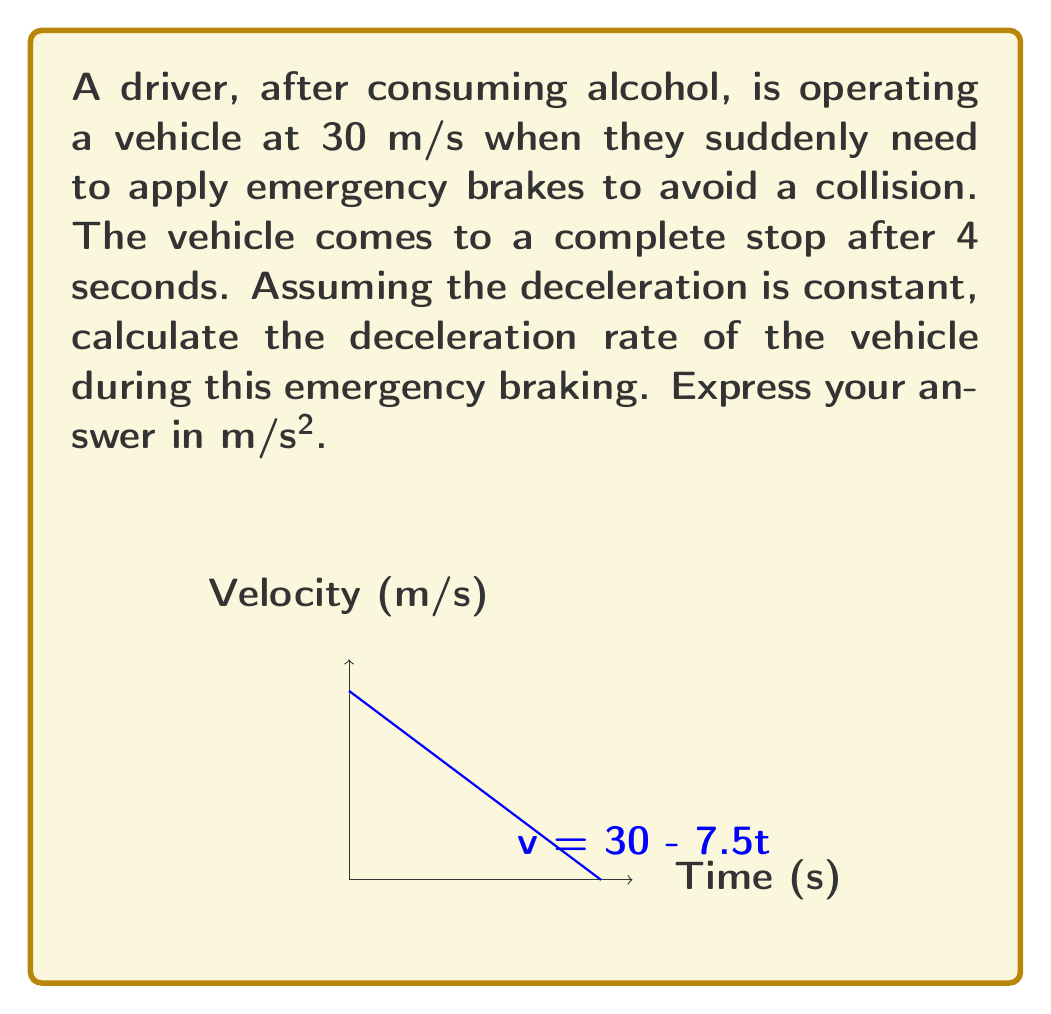Show me your answer to this math problem. To solve this problem, we'll use the equation of motion for constant acceleration:

$$ v = v_0 + at $$

Where:
$v$ = final velocity (0 m/s)
$v_0$ = initial velocity (30 m/s)
$a$ = acceleration (deceleration in this case, which we need to find)
$t$ = time (4 seconds)

Let's substitute these values into the equation:

$$ 0 = 30 + a(4) $$

Now, we can solve for $a$:

$$ -30 = 4a $$
$$ a = -\frac{30}{4} = -7.5 \text{ m/s²} $$

The negative sign indicates that it's a deceleration (slowing down).

We can verify this using the displacement equation:

$$ s = v_0t + \frac{1}{2}at^2 $$

$$ s = (30)(4) + \frac{1}{2}(-7.5)(4^2) = 120 - 60 = 60 \text{ m} $$

This shows that the vehicle traveled 60 meters before stopping, which is reasonable for emergency braking from 30 m/s (about 67 mph).
Answer: $-7.5 \text{ m/s²}$ 